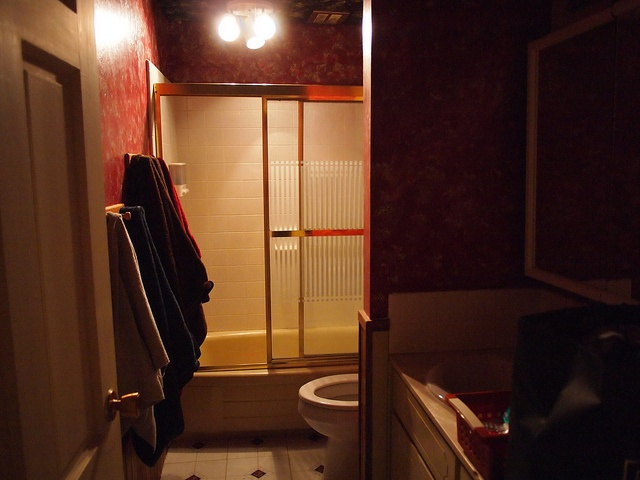Describe the objects in this image and their specific colors. I can see toilet in maroon, black, and tan tones and sink in maroon, black, and brown tones in this image. 